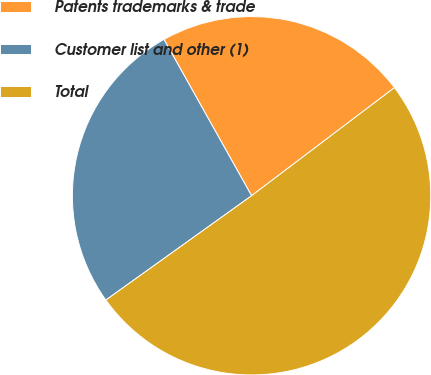Convert chart. <chart><loc_0><loc_0><loc_500><loc_500><pie_chart><fcel>Patents trademarks & trade<fcel>Customer list and other (1)<fcel>Total<nl><fcel>22.82%<fcel>26.76%<fcel>50.42%<nl></chart> 